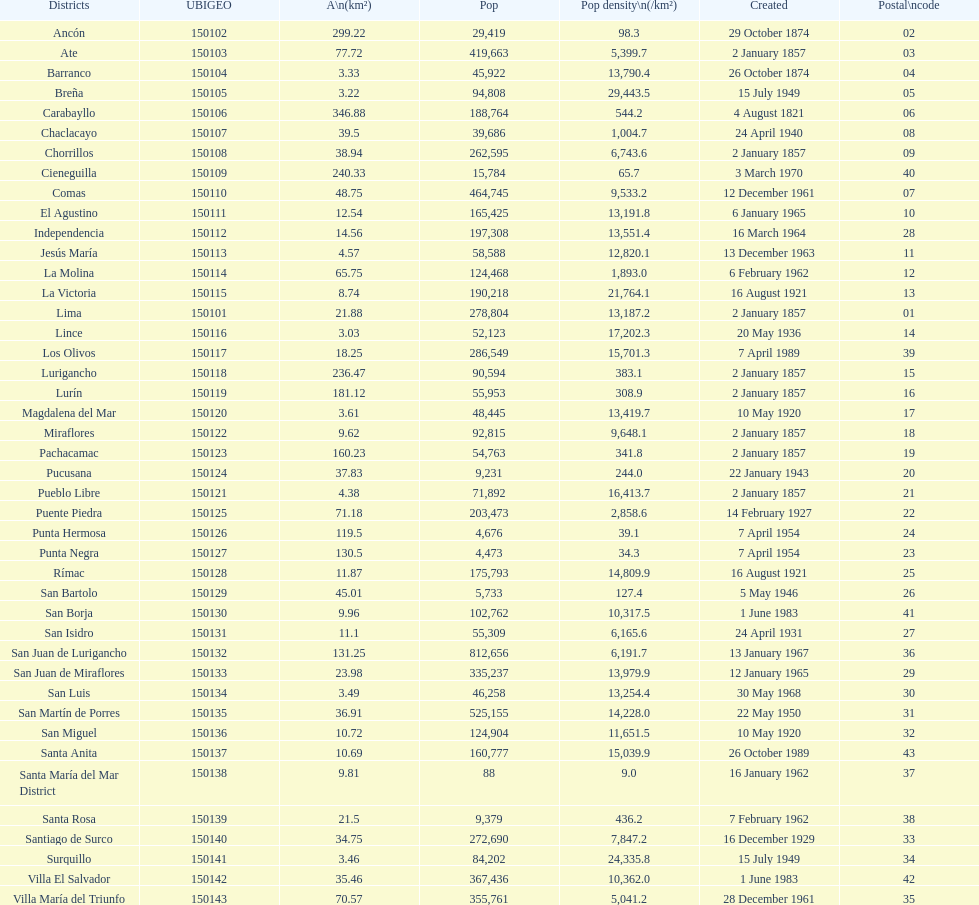How many districts are there in this city? 43. 